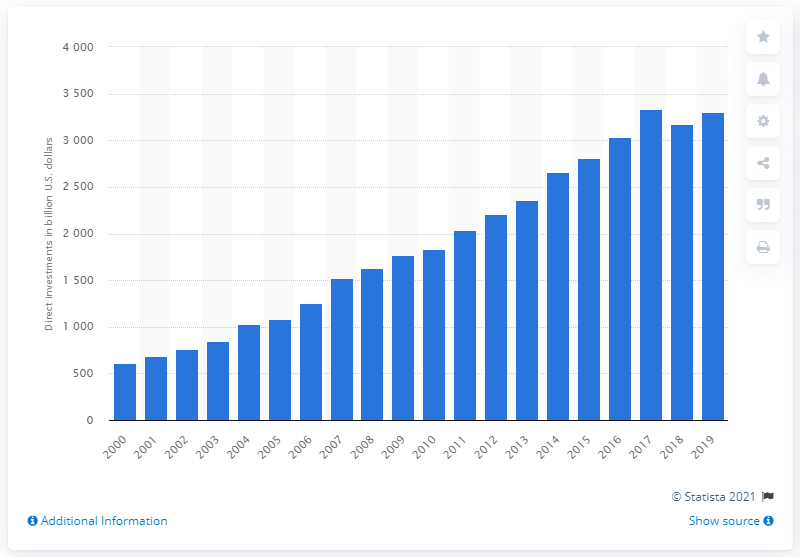What's represented in this image? The image depicts a bar chart showing the United States direct investments in the European Union from the year 2000 to 2019.  Which year shows the highest amount of investment? According to the bar chart in the image, the year 2019 shows the highest amount of United States direct investments in the European Union. 